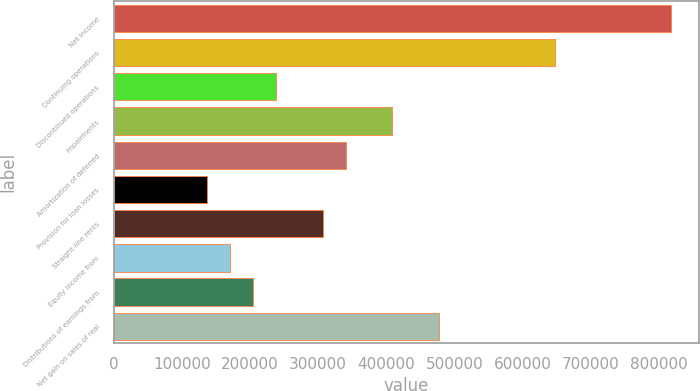<chart> <loc_0><loc_0><loc_500><loc_500><bar_chart><fcel>Net income<fcel>Continuing operations<fcel>Discontinued operations<fcel>Impairments<fcel>Amortization of deferred<fcel>Provision for loan losses<fcel>Straight-line rents<fcel>Equity income from<fcel>Distributions of earnings from<fcel>Net gain on sales of real<nl><fcel>817990<fcel>647588<fcel>238623<fcel>409025<fcel>340864<fcel>136382<fcel>306784<fcel>170462<fcel>204542<fcel>477186<nl></chart> 